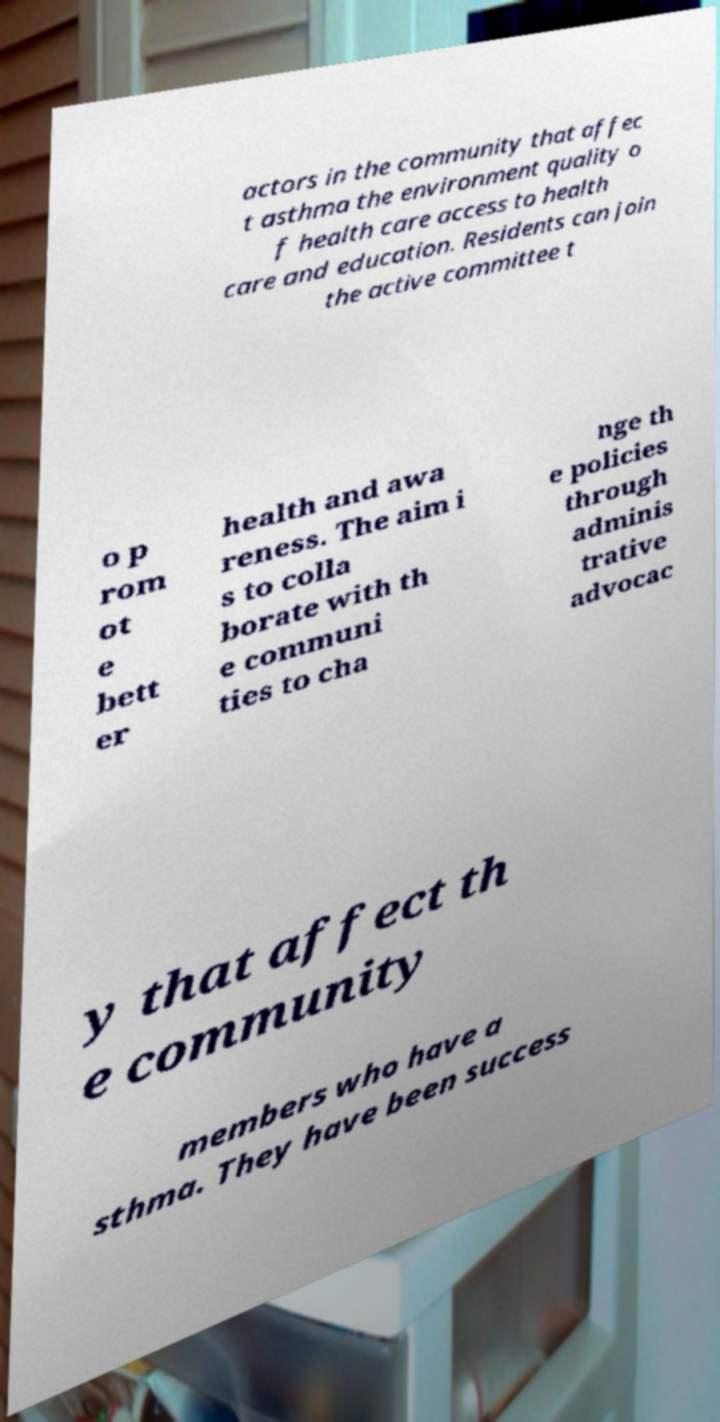Can you read and provide the text displayed in the image?This photo seems to have some interesting text. Can you extract and type it out for me? actors in the community that affec t asthma the environment quality o f health care access to health care and education. Residents can join the active committee t o p rom ot e bett er health and awa reness. The aim i s to colla borate with th e communi ties to cha nge th e policies through adminis trative advocac y that affect th e community members who have a sthma. They have been success 